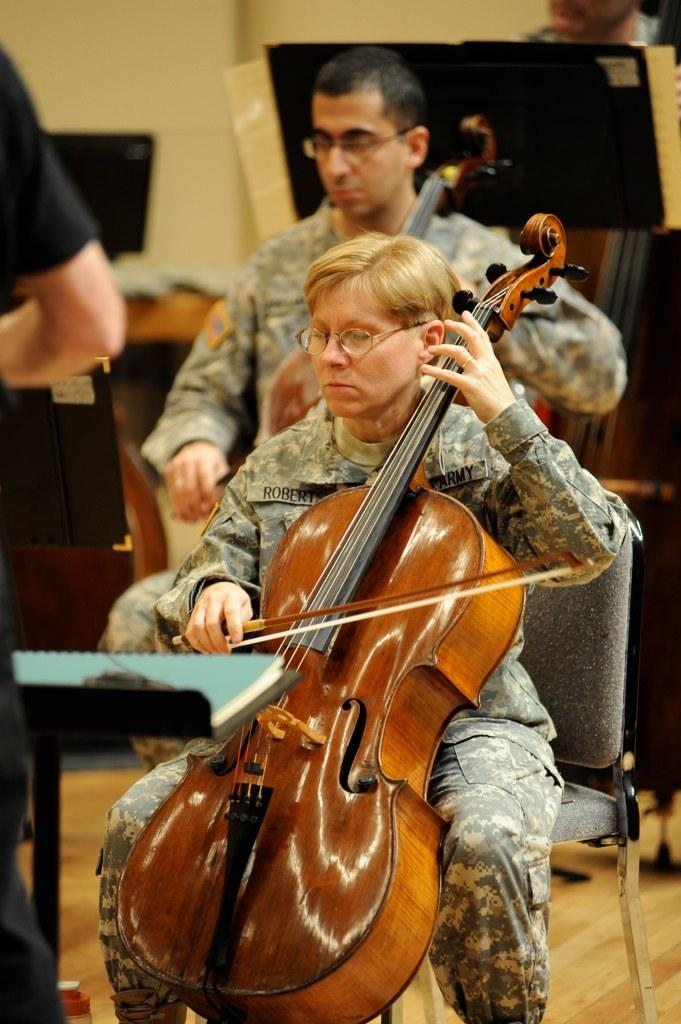How many people are seated in the image? There are two people seated in the image. What are the seated people doing? One of the seated people is playing a violin. What is the position of the standing person in the image? There is a person standing in the image. What type of bears can be seen sitting on the throne in the image? There are no bears or thrones present in the image. Can you tell me how many people are floating in space in the image? There is no indication of space or floating people in the image. 